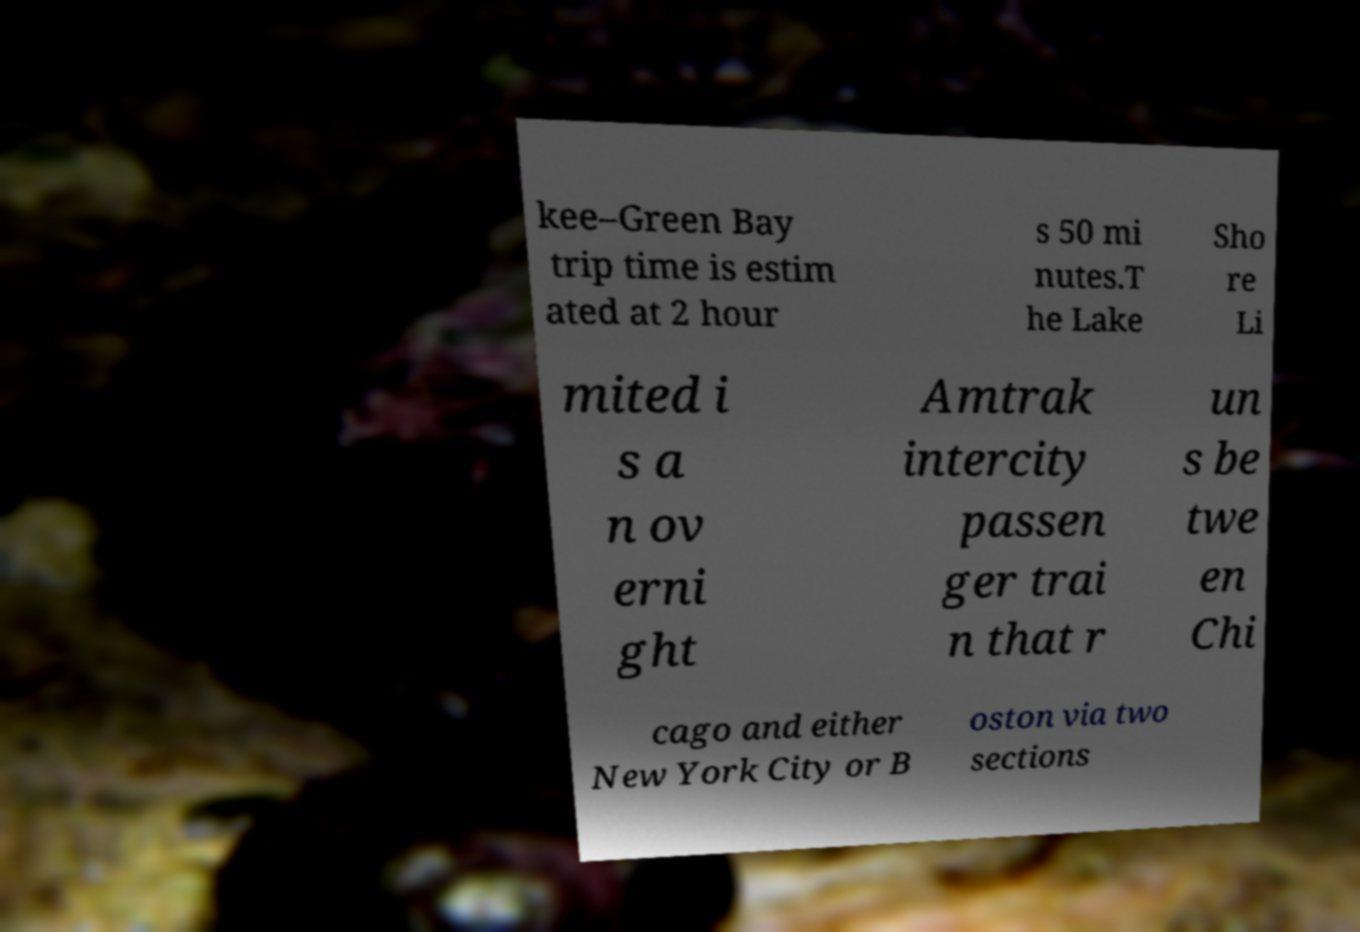Please identify and transcribe the text found in this image. kee–Green Bay trip time is estim ated at 2 hour s 50 mi nutes.T he Lake Sho re Li mited i s a n ov erni ght Amtrak intercity passen ger trai n that r un s be twe en Chi cago and either New York City or B oston via two sections 